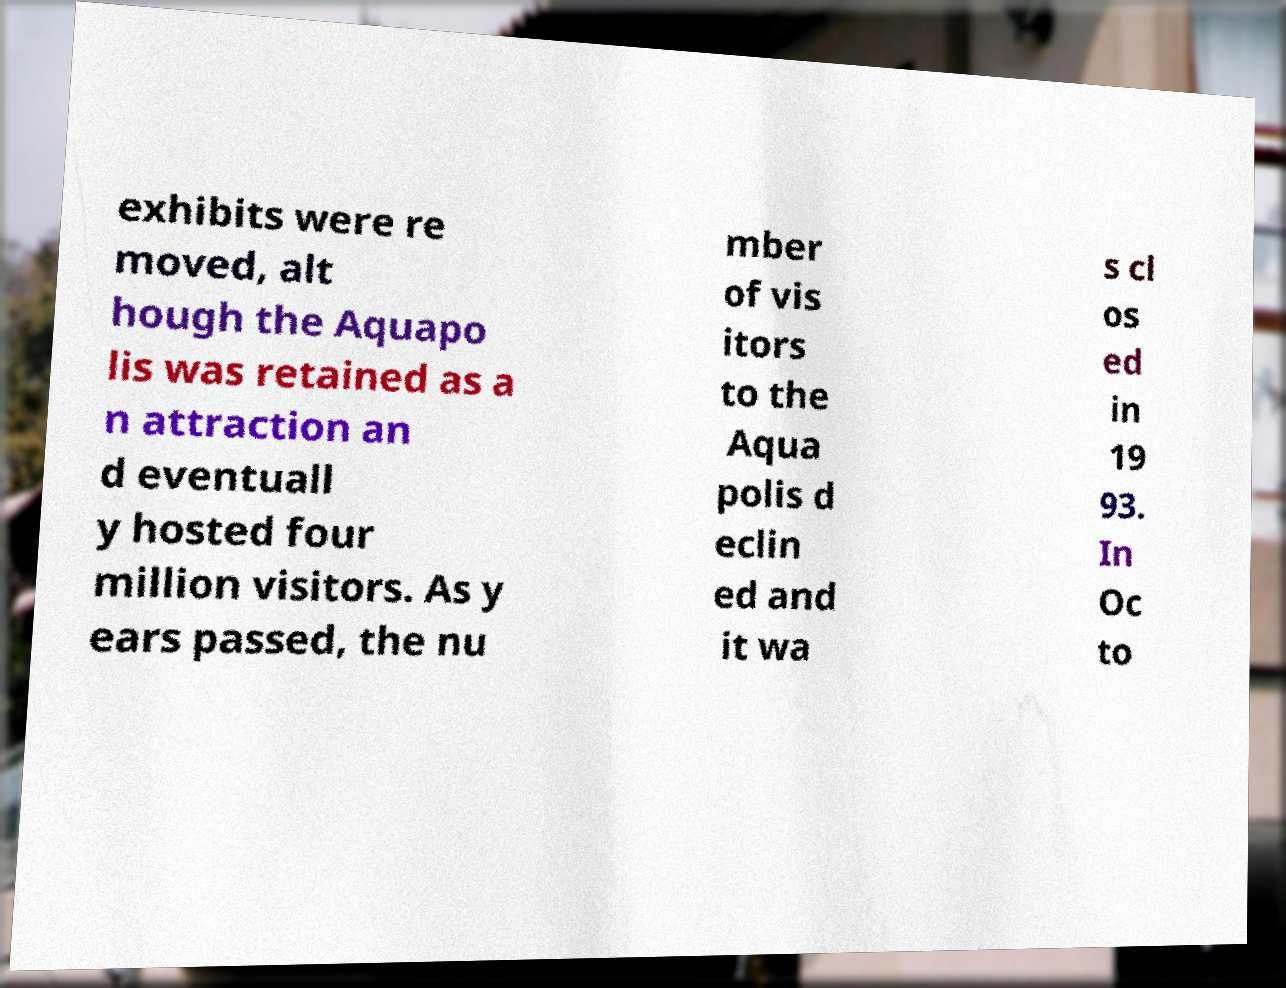Could you assist in decoding the text presented in this image and type it out clearly? exhibits were re moved, alt hough the Aquapo lis was retained as a n attraction an d eventuall y hosted four million visitors. As y ears passed, the nu mber of vis itors to the Aqua polis d eclin ed and it wa s cl os ed in 19 93. In Oc to 